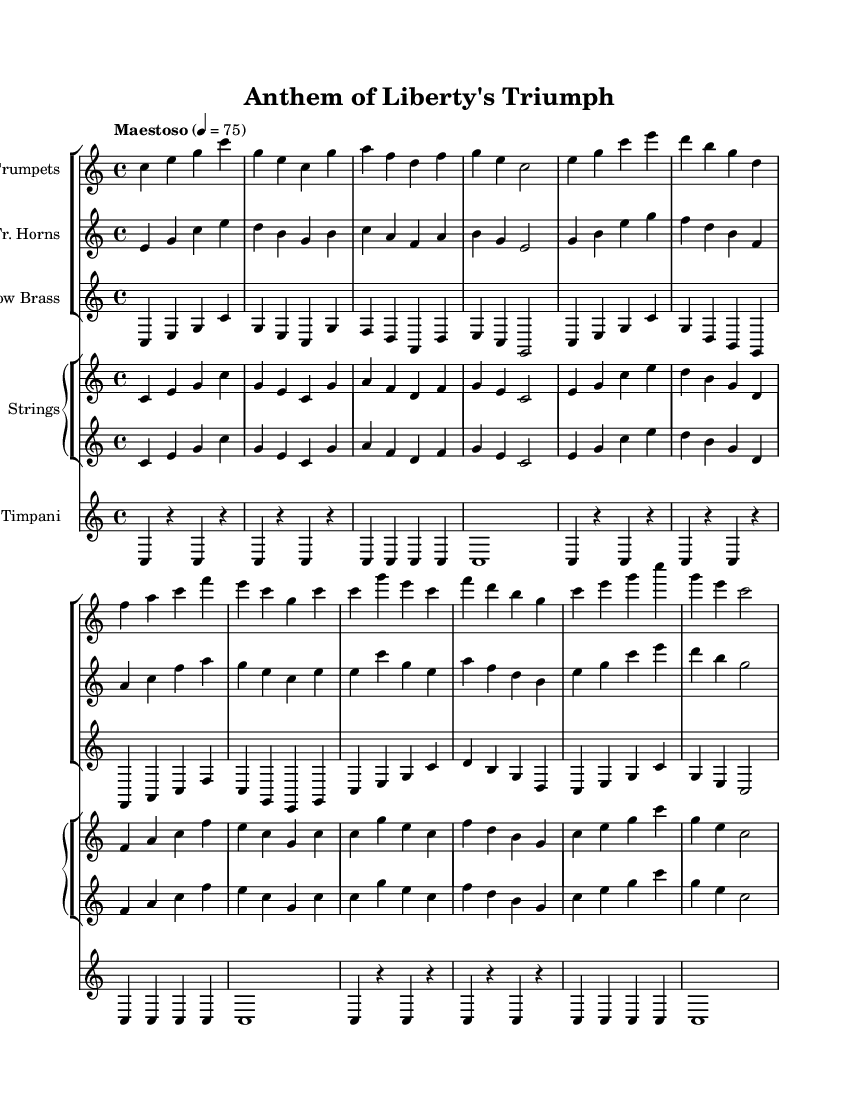What is the key signature of this music? The key signature is C major, indicated by the absence of sharps or flats on the staff.
Answer: C major What is the time signature of this piece? The time signature is indicated at the beginning of the score, which shows there are four beats in each measure.
Answer: 4/4 What is the tempo marking used in this orchestral piece? The tempo marking "Maestoso" indicates a majestic and stately pace, which is further defined by the metronome marking of quarter note equals seventy-five beats per minute.
Answer: Maestoso Which instruments are included in this score? The instruments listed in the score include Trumpets, French Horns, Low Brass, Strings, and Timpani, as indicated in the staff groups.
Answer: Trumpets, French Horns, Low Brass, Strings, Timpani How many measures does the music have before the first rest? The first rest appears in the Timpani part after three measures, meaning there are three measures before any rest occurs.
Answer: 3 What is the highest note played by the trumpets? Analyzing the Trumpets staff, the highest note played is a g' in the second measure.
Answer: g' Explain the overall structure of the orchestration. The orchestration consists of multiple sections where three groups of instruments are displayed. Each group serves a different role; the Trumpets, French Horns, and Low Brass form the brass section, while the Strings are divided across two staves, and the Timpani provides rhythmic support as a percussion instrument. The distinct instrumental lines work together to create a cohesive orchestral sound.
Answer: Brass section, Strings, Timpani 